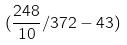<formula> <loc_0><loc_0><loc_500><loc_500>( \frac { 2 4 8 } { 1 0 } / 3 7 2 - 4 3 )</formula> 